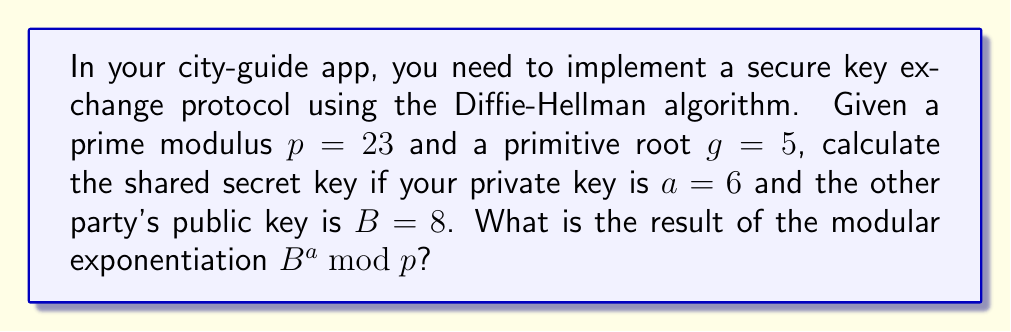Give your solution to this math problem. To calculate the shared secret key using the Diffie-Hellman key exchange protocol, we need to perform modular exponentiation. The formula is:

$$K = B^a \bmod p$$

Where:
$K$ is the shared secret key
$B$ is the other party's public key
$a$ is your private key
$p$ is the prime modulus

Given values:
$B = 8$
$a = 6$
$p = 23$

Let's calculate step by step:

1) We need to compute $8^6 \bmod 23$

2) We can use the square and multiply algorithm to efficiently calculate this:

   $8^2 \bmod 23 = 64 \bmod 23 = 18$
   $8^4 \bmod 23 = 18^2 \bmod 23 = 324 \bmod 23 = 2$
   $8^6 \bmod 23 = (8^4 \cdot 8^2) \bmod 23 = (2 \cdot 18) \bmod 23 = 36 \bmod 23 = 13$

3) Therefore, the shared secret key is 13.

This value can now be used as a symmetric key for secure communication in your city-guide app.
Answer: $13$ 